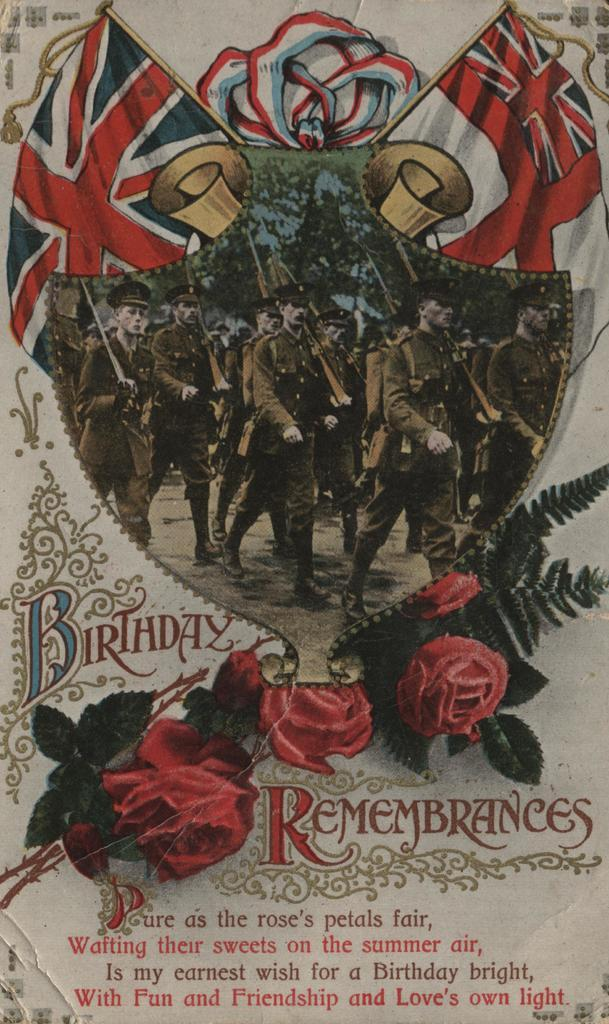<image>
Share a concise interpretation of the image provided. A portrait of old time soldiers contains the title Birthday Remembrances. 